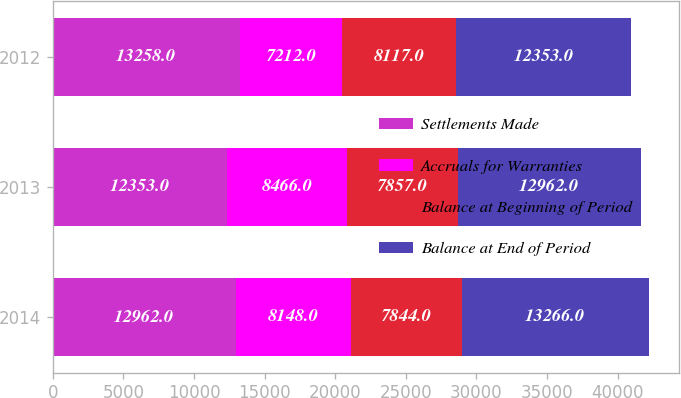<chart> <loc_0><loc_0><loc_500><loc_500><stacked_bar_chart><ecel><fcel>2014<fcel>2013<fcel>2012<nl><fcel>Settlements Made<fcel>12962<fcel>12353<fcel>13258<nl><fcel>Accruals for Warranties<fcel>8148<fcel>8466<fcel>7212<nl><fcel>Balance at Beginning of Period<fcel>7844<fcel>7857<fcel>8117<nl><fcel>Balance at End of Period<fcel>13266<fcel>12962<fcel>12353<nl></chart> 